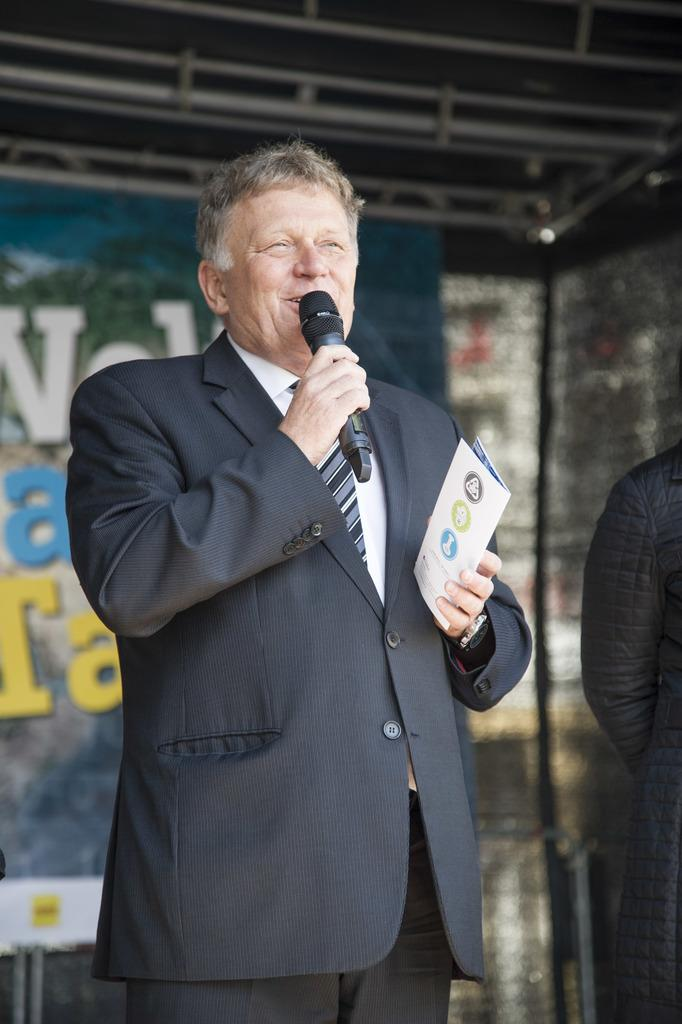Who is present in the image? There is a person in the image. What is the person wearing? The person is wearing a blazer. What object is the person holding? The person is holding a microphone. What is the person doing with the microphone? The person is speaking. What type of cake is the person tasting in the image? There is no cake present in the image, and the person is not tasting anything. 